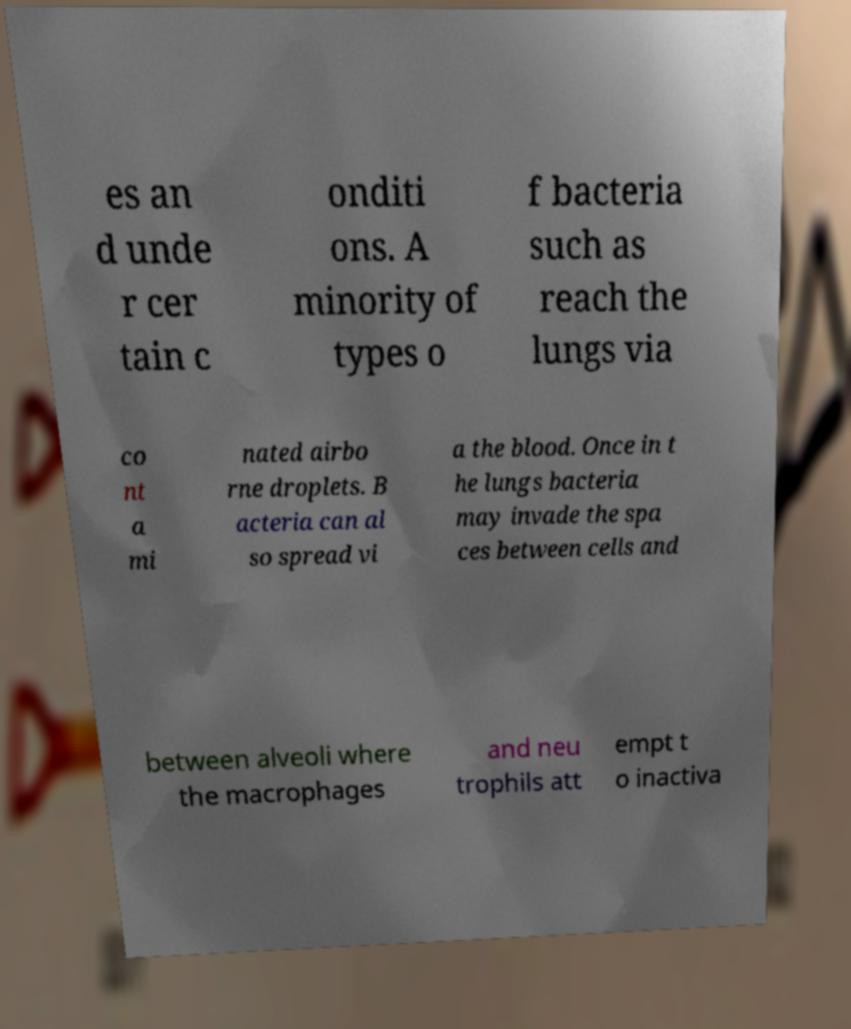Can you accurately transcribe the text from the provided image for me? es an d unde r cer tain c onditi ons. A minority of types o f bacteria such as reach the lungs via co nt a mi nated airbo rne droplets. B acteria can al so spread vi a the blood. Once in t he lungs bacteria may invade the spa ces between cells and between alveoli where the macrophages and neu trophils att empt t o inactiva 